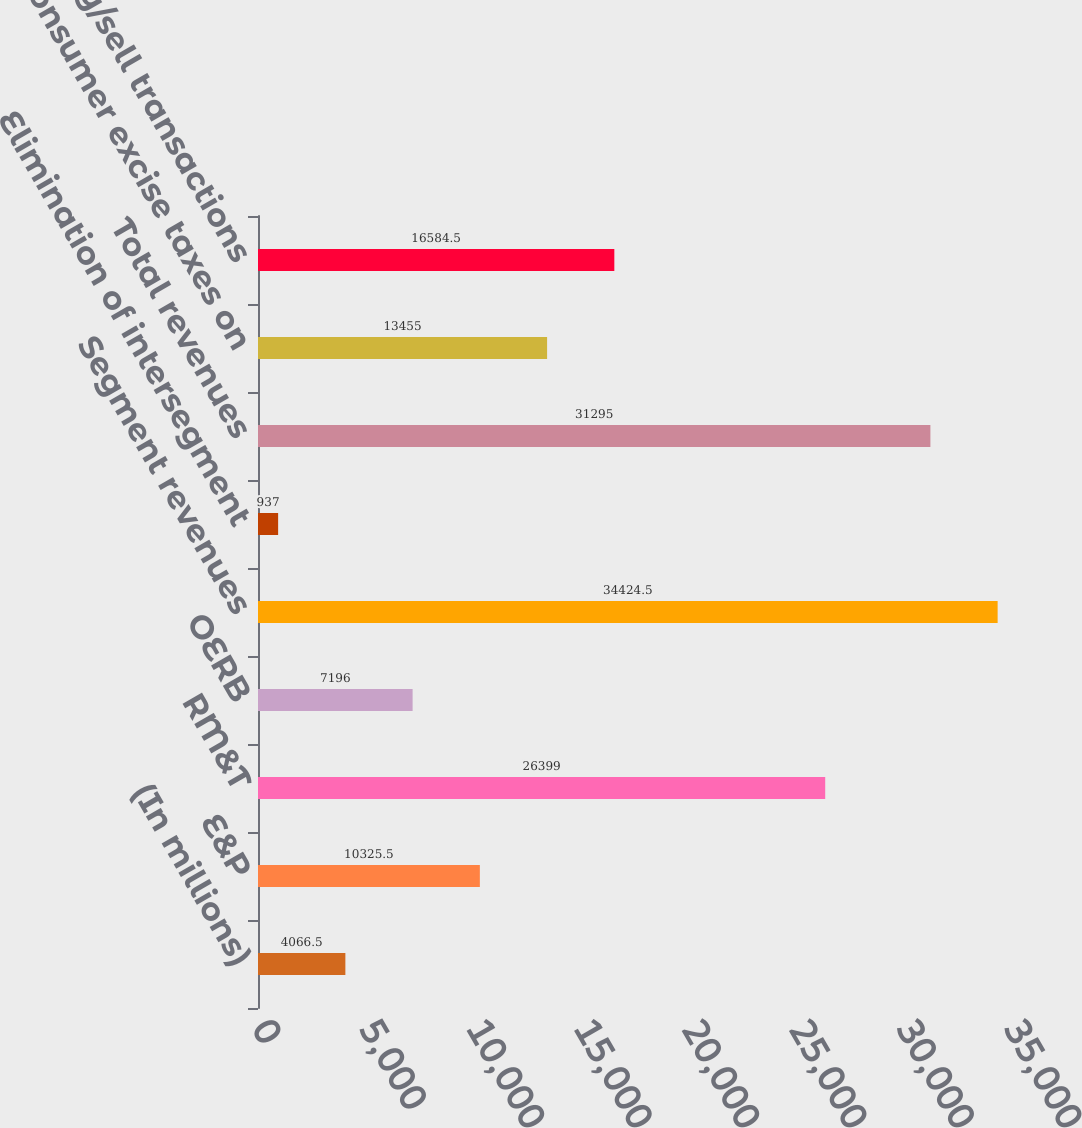<chart> <loc_0><loc_0><loc_500><loc_500><bar_chart><fcel>(In millions)<fcel>E&P<fcel>RM&T<fcel>OERB<fcel>Segment revenues<fcel>Elimination of intersegment<fcel>Total revenues<fcel>Consumer excise taxes on<fcel>Total buy/sell transactions<nl><fcel>4066.5<fcel>10325.5<fcel>26399<fcel>7196<fcel>34424.5<fcel>937<fcel>31295<fcel>13455<fcel>16584.5<nl></chart> 